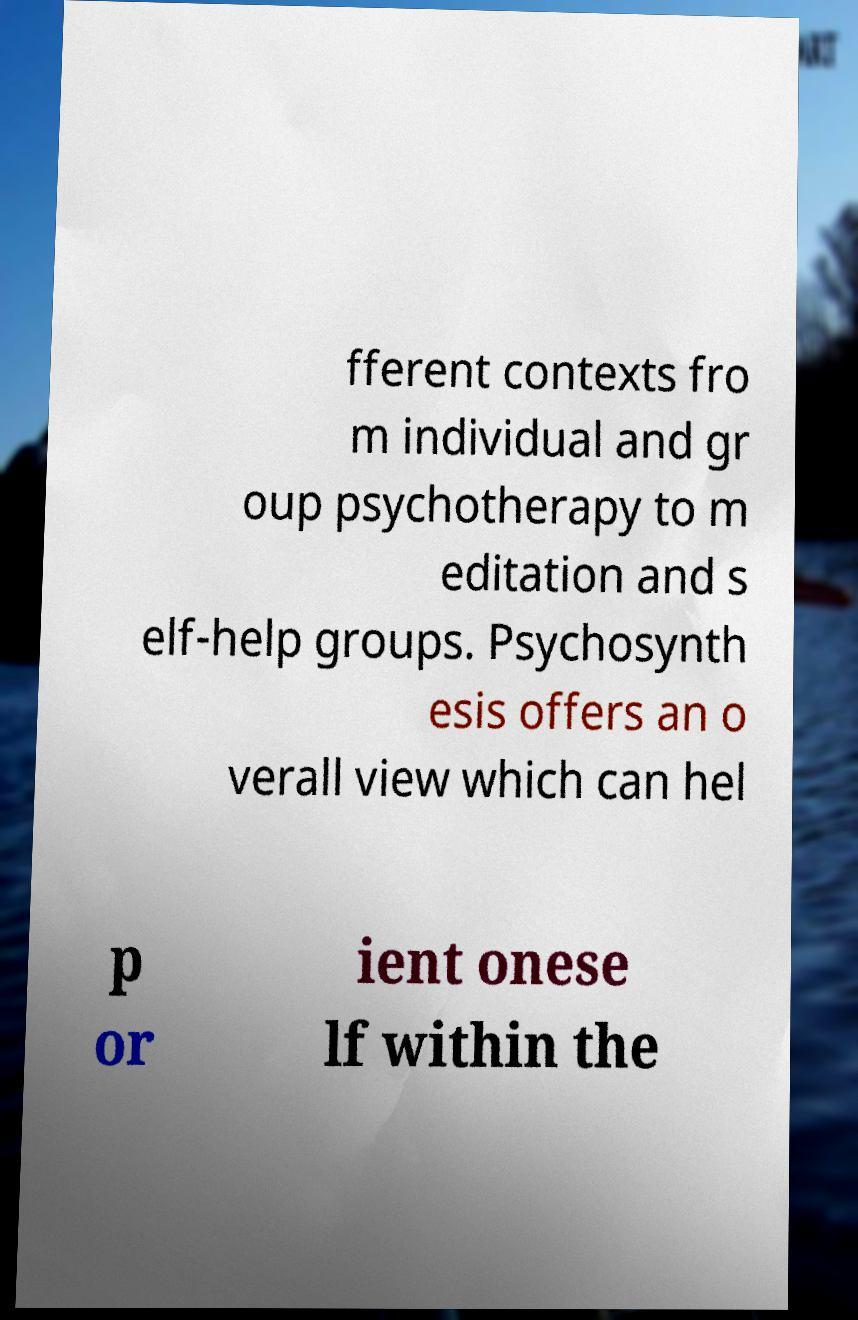For documentation purposes, I need the text within this image transcribed. Could you provide that? fferent contexts fro m individual and gr oup psychotherapy to m editation and s elf-help groups. Psychosynth esis offers an o verall view which can hel p or ient onese lf within the 